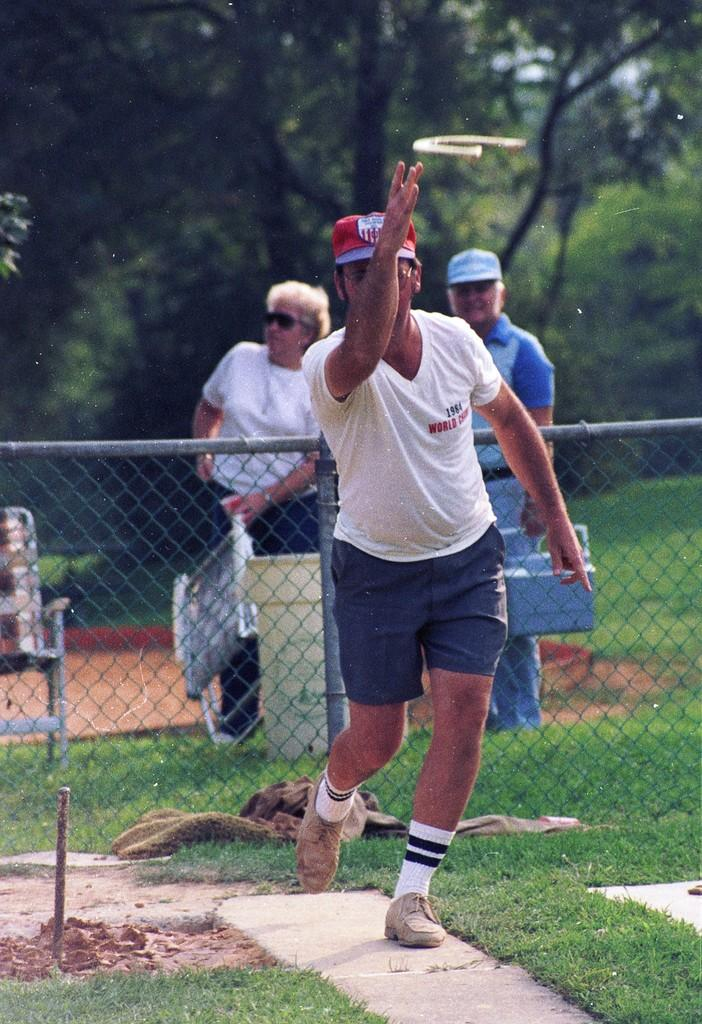How many people are in the image? There are three persons in the image. What is one of the persons doing in the image? One of the persons is throwing an object. What type of furniture can be seen in the image? There are chairs in the image. What type of barrier is present in the image? There is fencing in the image. What type of ground surface is visible in the image? Grass is present in the image. What type of vegetation is visible in the image? There are trees in the image. What object can be seen on the ground in the image? There is an object on the ground in the image. What type of train is visible in the image? There is no train present in the image. What type of authority figure can be seen in the image? There is no authority figure present in the image. 